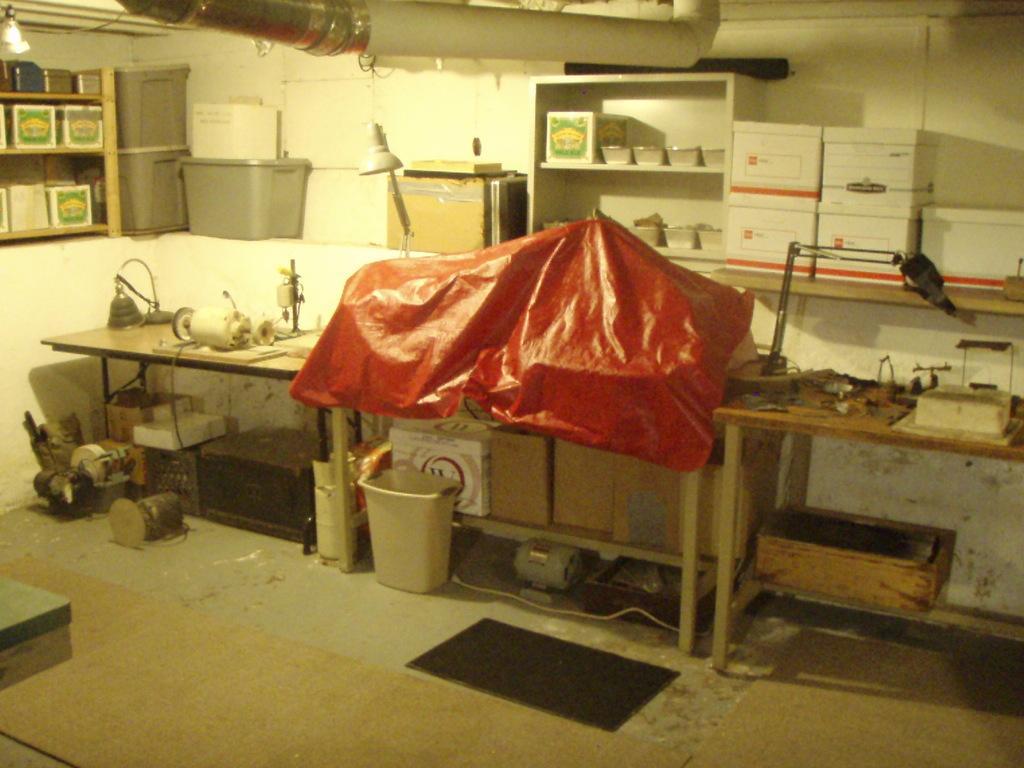How would you summarize this image in a sentence or two? On this tables there are objects. Under this table there are cardboard boxes, bin and things. In these racks there are boxes and objects. Here we can see containers. This is lamp. 